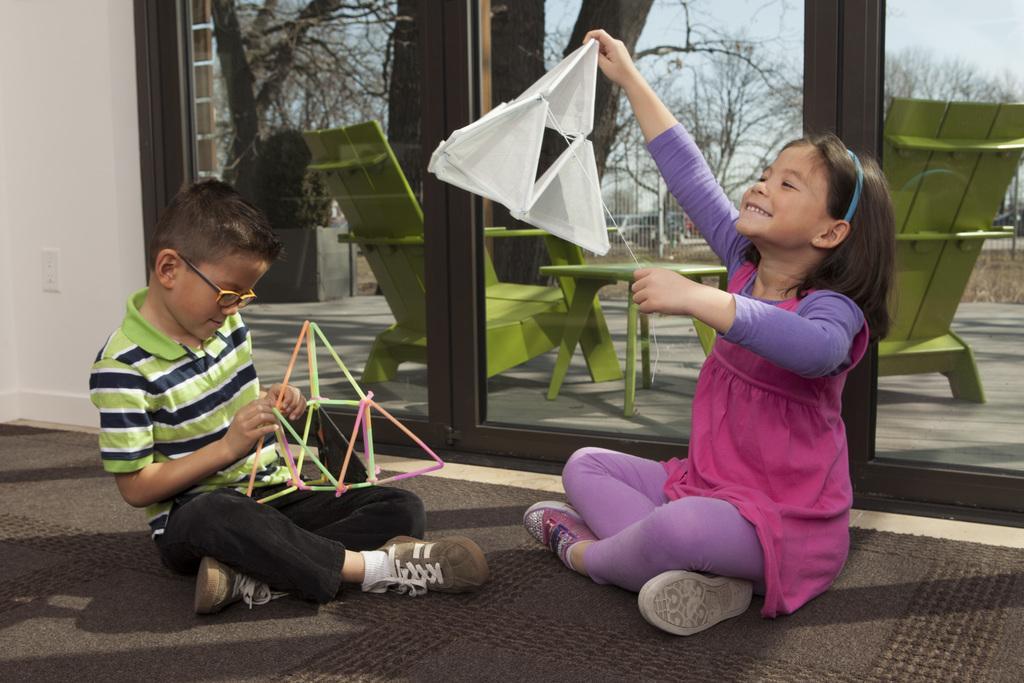Could you give a brief overview of what you see in this image? In the picture I can see a boy and a girl are sitting on the floor. These two kids are holding some objects in hands. In the background I can see framed glass wall, green color chairs, a table, trees, the sky and some other objects. 